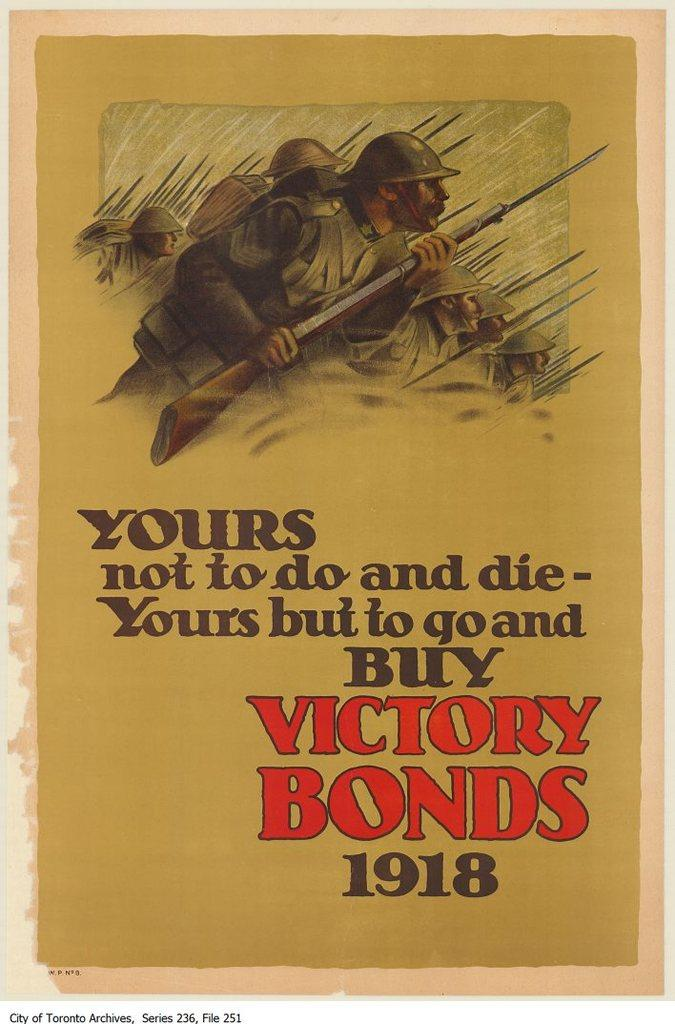<image>
Write a terse but informative summary of the picture. Cover from 1918 that shows a group of soldiers. 